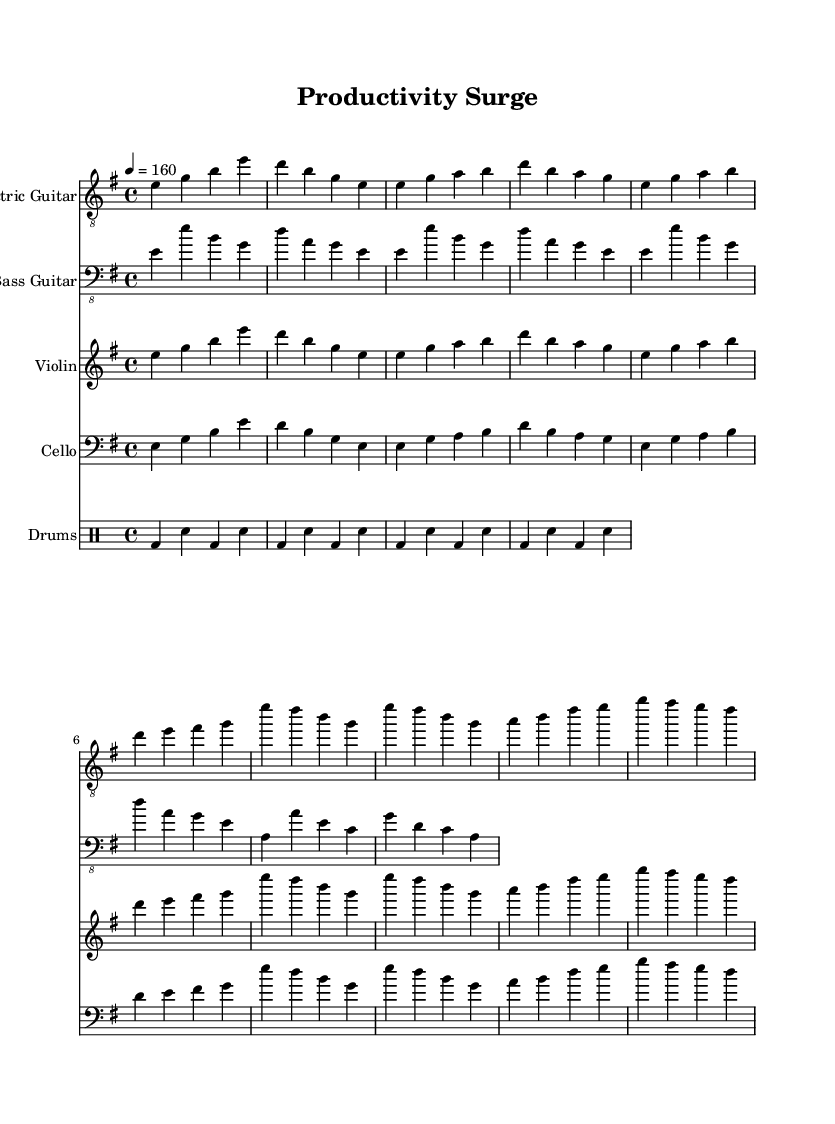What is the key signature of this music? The key signature is E minor, which has one sharp (F#). This is indicated at the beginning of the staff.
Answer: E minor What is the time signature of this music? The time signature is 4/4, which means there are four beats in each measure and the quarter note gets one beat. This can be found at the beginning of the score.
Answer: 4/4 What is the tempo marking for this piece? The tempo marking indicates a speed of 160 beats per minute, specified as "4 = 160". This directs musicians on how fast to play the piece.
Answer: 160 How many measures are in the electric guitar part? By counting the number of vertical lines in the electric guitar part, each of which represents a measure, we find there are five measures.
Answer: 5 Which instrument plays the lowest notes? The bass guitar part is designed to play the lowest range of pitches, indicated by its placement on the staff and playing in lower octaves compared to the other instruments.
Answer: Bass Guitar What primary rhythmic pattern is used in the drum part? The drum part predominantly consists of bass drum and snare drum hits alternating in a steady pattern, evidenced by the alternating notes on the staff.
Answer: Alternating What type of musical fusion is represented in this piece? The piece combines elements of rock and classical genres, typically characterized by the presence of electric guitar along with orchestral strings. This fusion is evident in the instrumentation.
Answer: Rock-Classical 